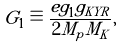<formula> <loc_0><loc_0><loc_500><loc_500>G _ { 1 } \equiv \frac { e g _ { 1 } g _ { K Y R } } { 2 M _ { p } M _ { K } } ,</formula> 